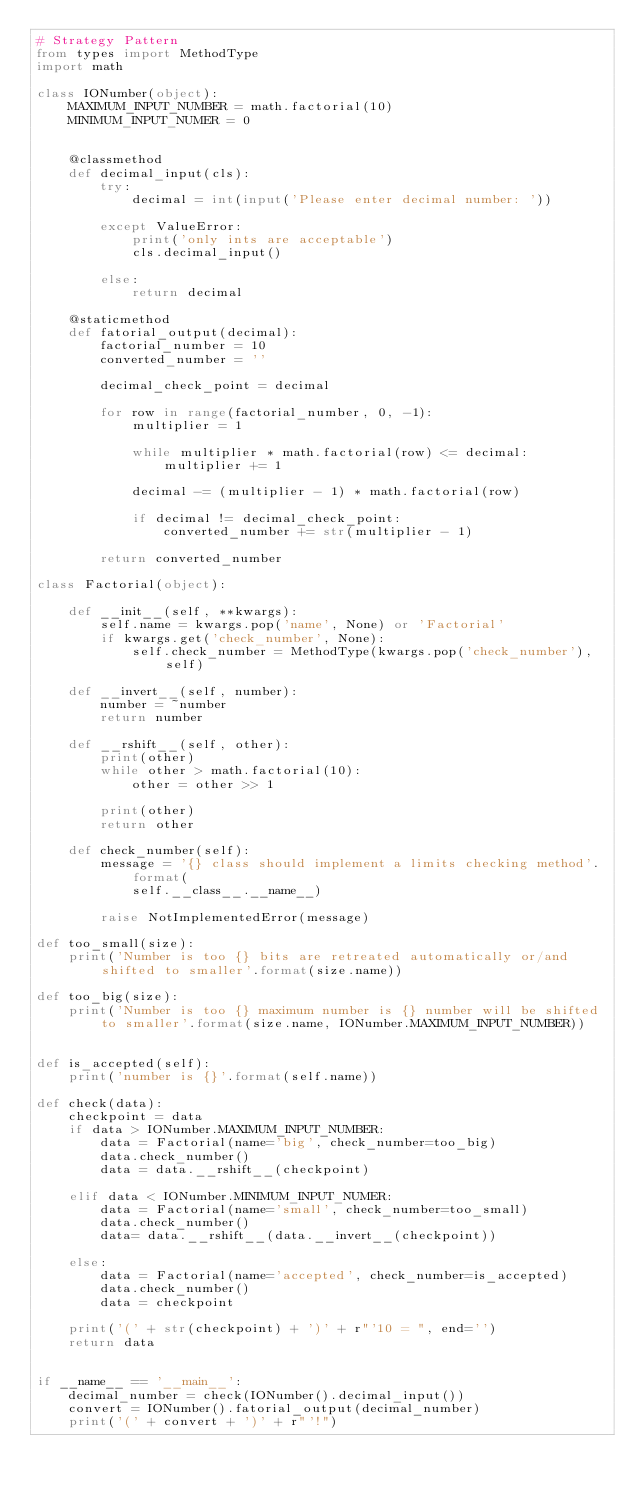<code> <loc_0><loc_0><loc_500><loc_500><_Python_># Strategy Pattern
from types import MethodType
import math

class IONumber(object):
    MAXIMUM_INPUT_NUMBER = math.factorial(10)
    MINIMUM_INPUT_NUMER = 0


    @classmethod
    def decimal_input(cls):
        try:
            decimal = int(input('Please enter decimal number: '))

        except ValueError:
            print('only ints are acceptable')
            cls.decimal_input()

        else:
            return decimal

    @staticmethod
    def fatorial_output(decimal):
        factorial_number = 10
        converted_number = ''

        decimal_check_point = decimal

        for row in range(factorial_number, 0, -1):
            multiplier = 1

            while multiplier * math.factorial(row) <= decimal:
                multiplier += 1

            decimal -= (multiplier - 1) * math.factorial(row)

            if decimal != decimal_check_point:
                converted_number += str(multiplier - 1)

        return converted_number

class Factorial(object):

    def __init__(self, **kwargs):
        self.name = kwargs.pop('name', None) or 'Factorial'
        if kwargs.get('check_number', None):
            self.check_number = MethodType(kwargs.pop('check_number'), self)

    def __invert__(self, number):
        number = ~number
        return number

    def __rshift__(self, other):
        print(other)
        while other > math.factorial(10):
            other = other >> 1

        print(other)
        return other

    def check_number(self):
        message = '{} class should implement a limits checking method'.format(
            self.__class__.__name__)

        raise NotImplementedError(message)

def too_small(size):
    print('Number is too {} bits are retreated automatically or/and shifted to smaller'.format(size.name))

def too_big(size):
    print('Number is too {} maximum number is {} number will be shifted to smaller'.format(size.name, IONumber.MAXIMUM_INPUT_NUMBER))


def is_accepted(self):
    print('number is {}'.format(self.name))

def check(data):
    checkpoint = data
    if data > IONumber.MAXIMUM_INPUT_NUMBER:
        data = Factorial(name='big', check_number=too_big)
        data.check_number()
        data = data.__rshift__(checkpoint)

    elif data < IONumber.MINIMUM_INPUT_NUMER:
        data = Factorial(name='small', check_number=too_small)
        data.check_number()
        data= data.__rshift__(data.__invert__(checkpoint))

    else:
        data = Factorial(name='accepted', check_number=is_accepted)
        data.check_number()
        data = checkpoint

    print('(' + str(checkpoint) + ')' + r"'10 = ", end='')
    return data


if __name__ == '__main__':
    decimal_number = check(IONumber().decimal_input())
    convert = IONumber().fatorial_output(decimal_number)
    print('(' + convert + ')' + r"'!")</code> 